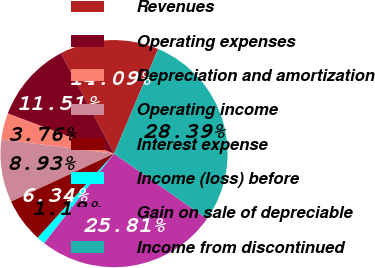<chart> <loc_0><loc_0><loc_500><loc_500><pie_chart><fcel>Revenues<fcel>Operating expenses<fcel>Depreciation and amortization<fcel>Operating income<fcel>Interest expense<fcel>Income (loss) before<fcel>Gain on sale of depreciable<fcel>Income from discontinued<nl><fcel>14.09%<fcel>11.51%<fcel>3.76%<fcel>8.93%<fcel>6.34%<fcel>1.18%<fcel>25.81%<fcel>28.39%<nl></chart> 